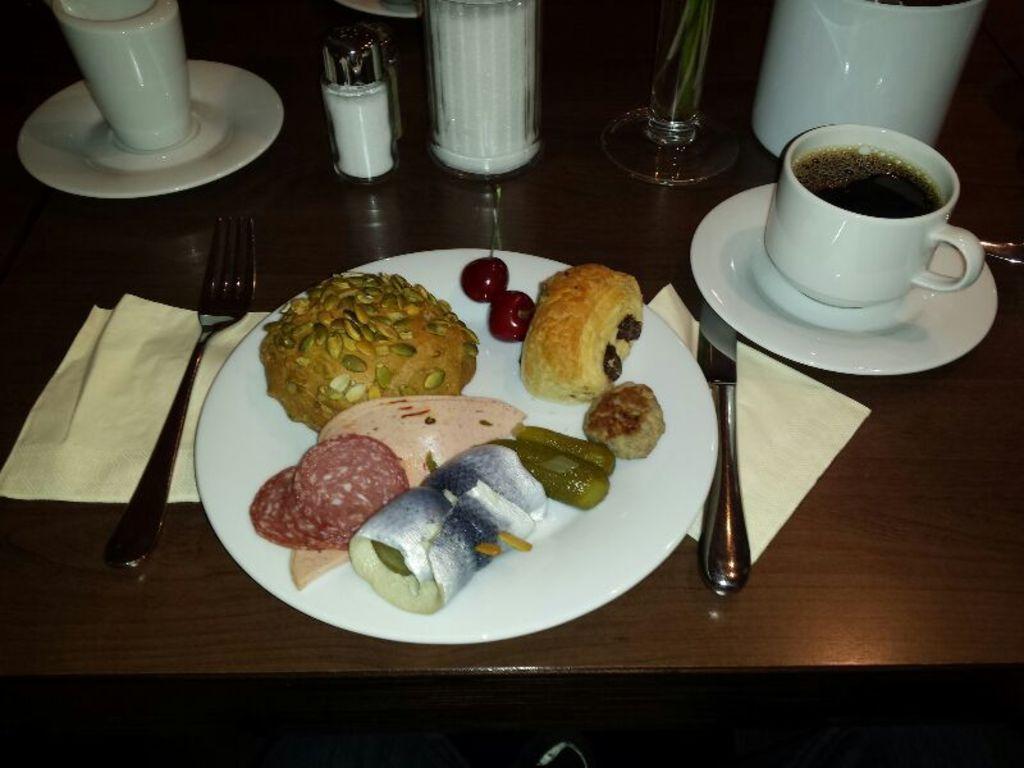How would you summarize this image in a sentence or two? Food is highlighted in this picture and it is presented on a plate. This plate is kept on a table. Beside this place there is a fork and the knife. This is a tissue which is in white color. These are 2 cherries. In a cup there is a coffee. This is a saucer. The table is in brown color. This is a container. This is a jar. 